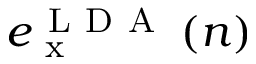<formula> <loc_0><loc_0><loc_500><loc_500>e _ { x } ^ { L D A } \left ( n \right )</formula> 